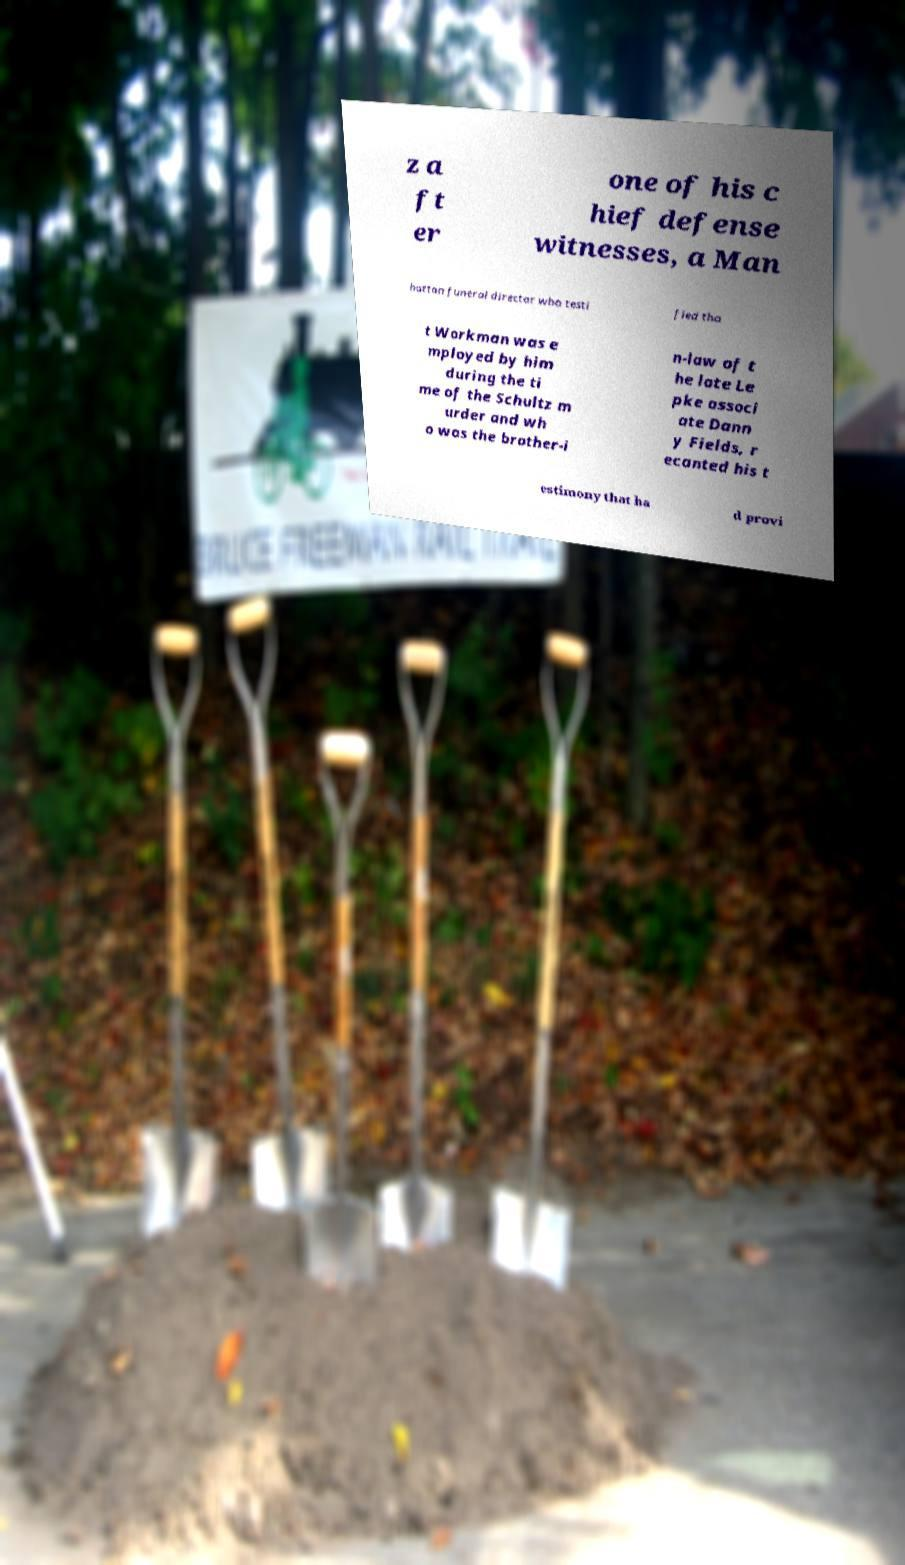What messages or text are displayed in this image? I need them in a readable, typed format. z a ft er one of his c hief defense witnesses, a Man hattan funeral director who testi fied tha t Workman was e mployed by him during the ti me of the Schultz m urder and wh o was the brother-i n-law of t he late Le pke associ ate Dann y Fields, r ecanted his t estimony that ha d provi 